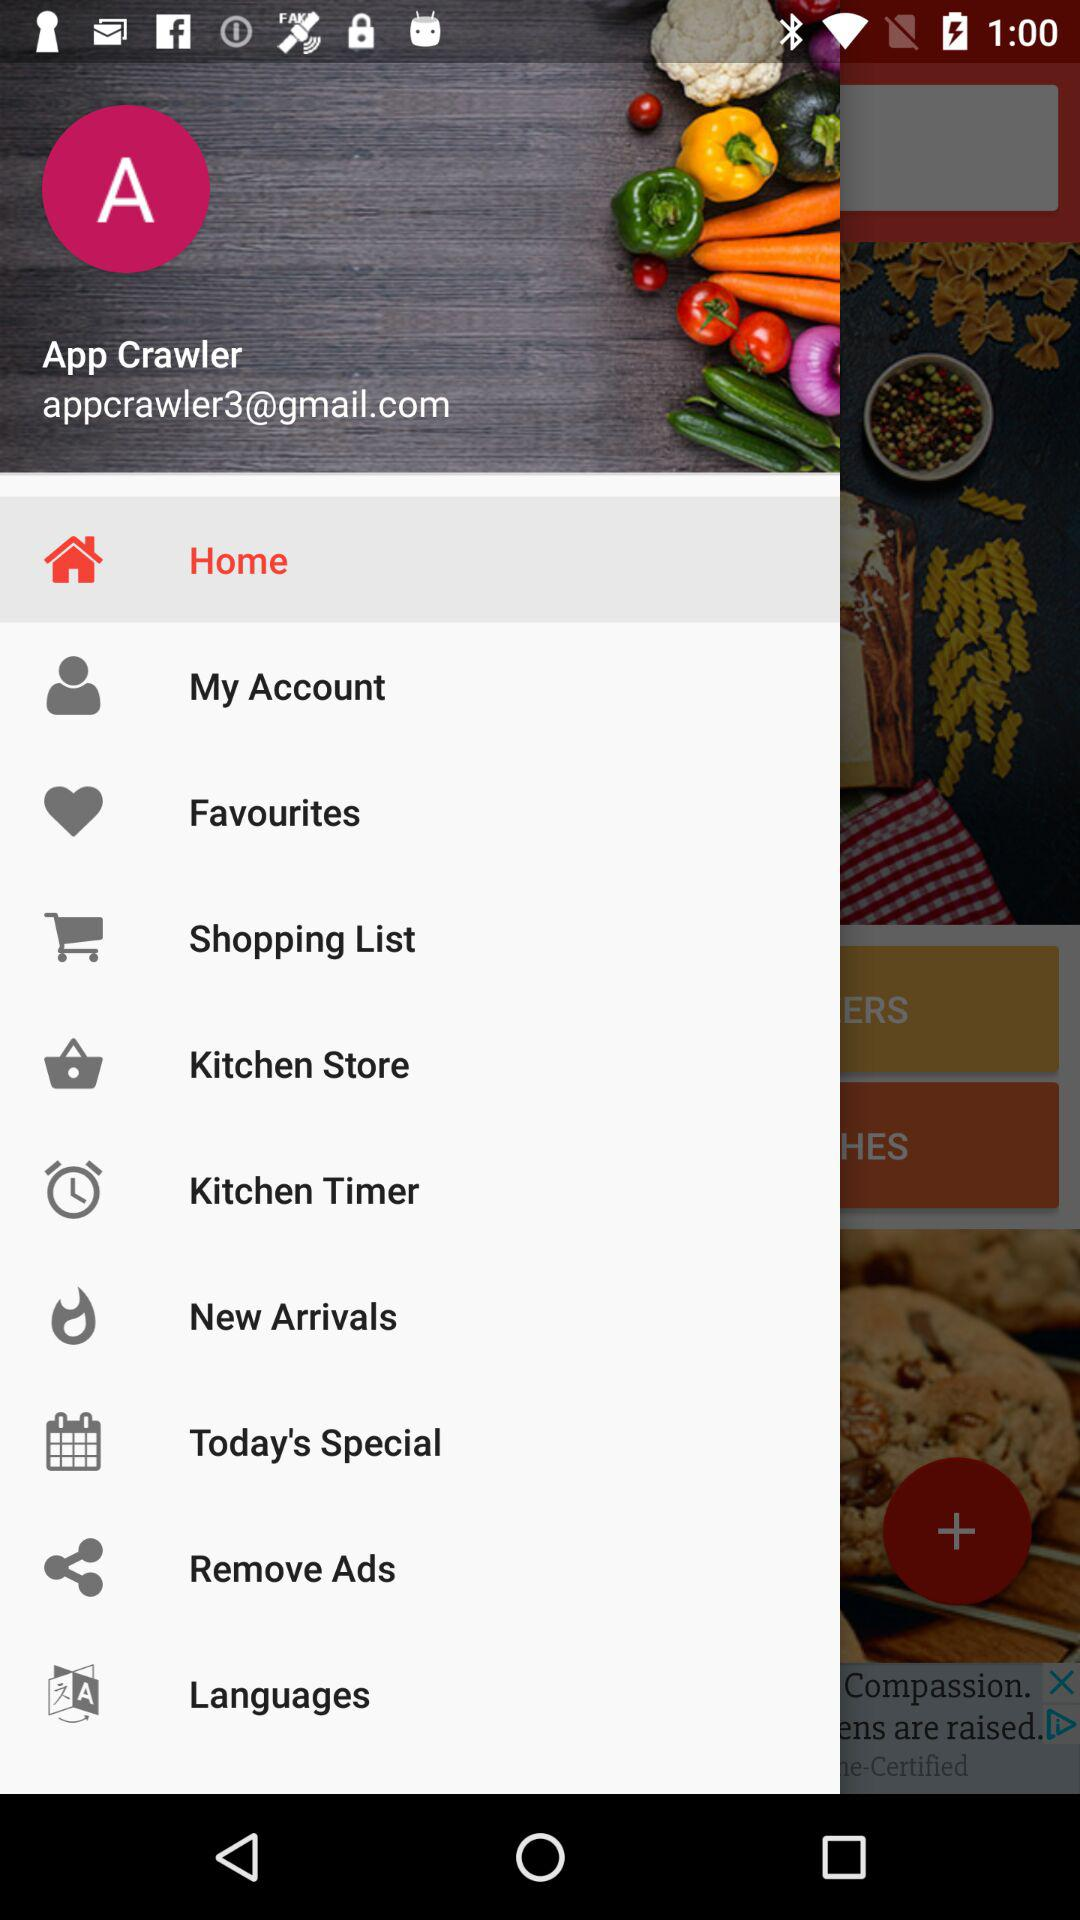What is a Gmail account? The Gmail account is appcrawler3@gmail.com. 